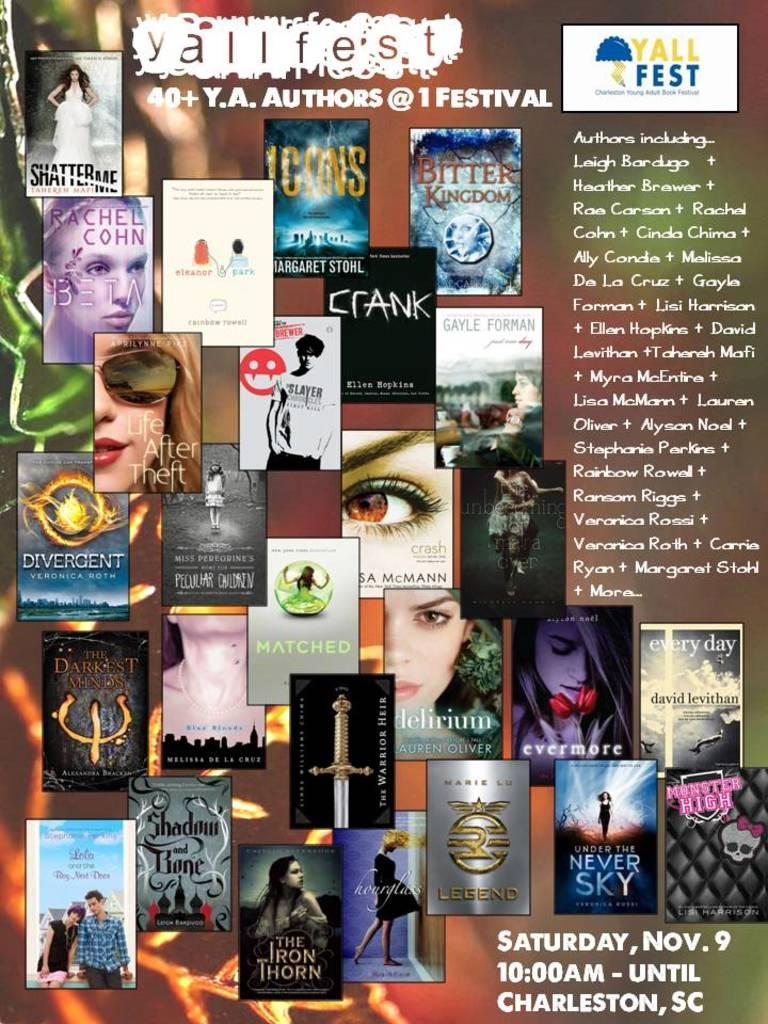Provide a one-sentence caption for the provided image. A poster advertising the Yall Fest being held at 10:00AM on Saturday, November 9th in Charleston, SC. 